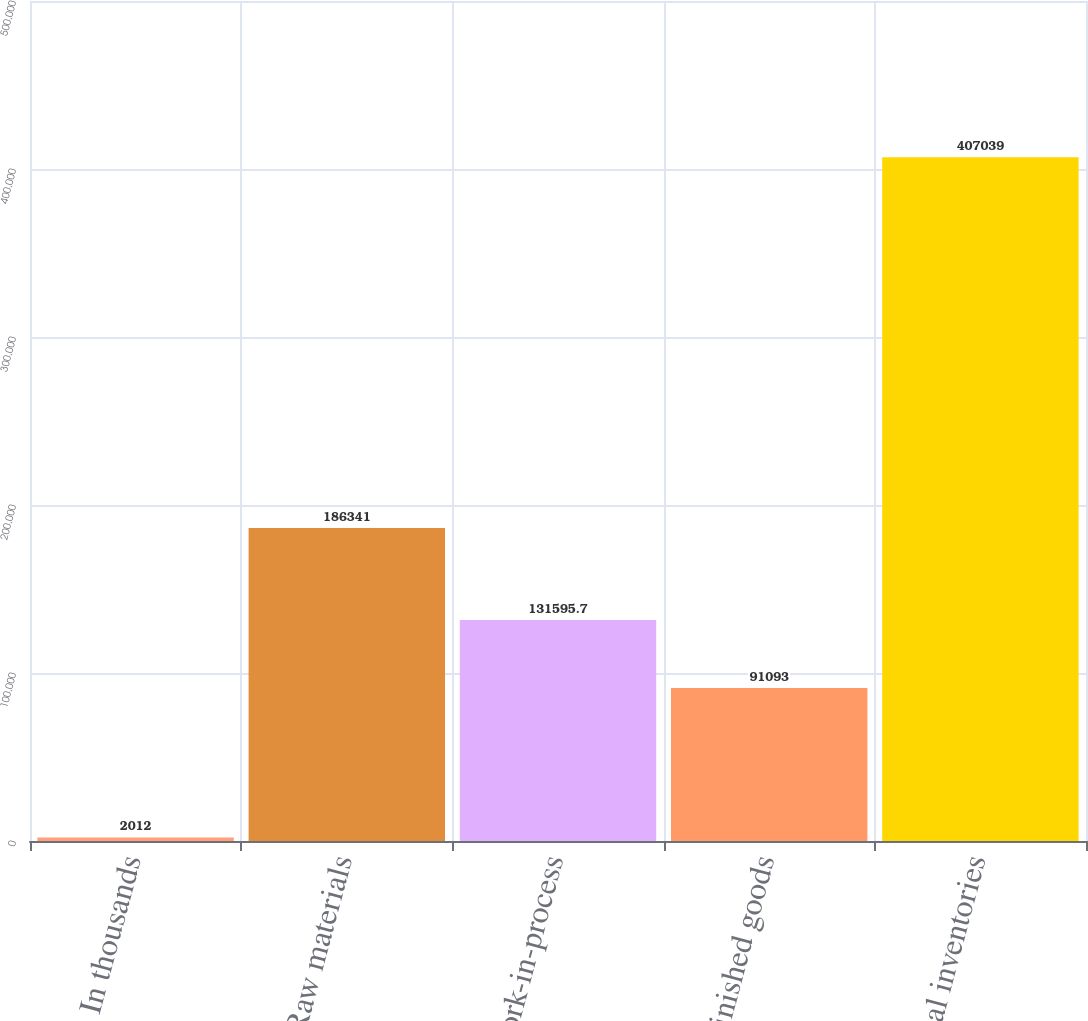Convert chart. <chart><loc_0><loc_0><loc_500><loc_500><bar_chart><fcel>In thousands<fcel>Raw materials<fcel>Work-in-process<fcel>Finished goods<fcel>Total inventories<nl><fcel>2012<fcel>186341<fcel>131596<fcel>91093<fcel>407039<nl></chart> 